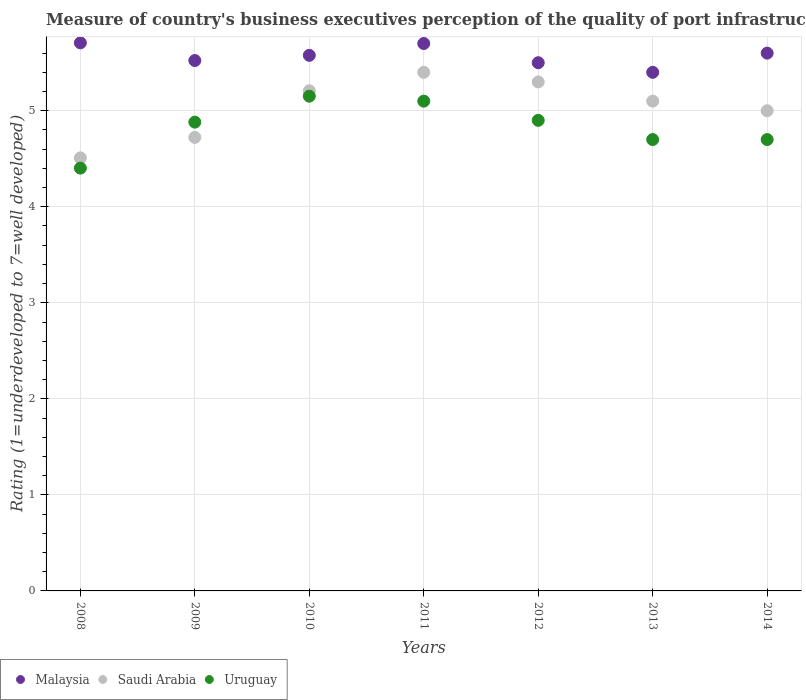How many different coloured dotlines are there?
Provide a short and direct response. 3. Is the number of dotlines equal to the number of legend labels?
Provide a short and direct response. Yes. What is the ratings of the quality of port infrastructure in Uruguay in 2014?
Ensure brevity in your answer.  4.7. Across all years, what is the maximum ratings of the quality of port infrastructure in Malaysia?
Provide a short and direct response. 5.71. In which year was the ratings of the quality of port infrastructure in Malaysia minimum?
Give a very brief answer. 2013. What is the total ratings of the quality of port infrastructure in Malaysia in the graph?
Your answer should be compact. 39.01. What is the difference between the ratings of the quality of port infrastructure in Malaysia in 2008 and that in 2010?
Make the answer very short. 0.13. What is the difference between the ratings of the quality of port infrastructure in Malaysia in 2013 and the ratings of the quality of port infrastructure in Saudi Arabia in 2012?
Give a very brief answer. 0.1. What is the average ratings of the quality of port infrastructure in Malaysia per year?
Your answer should be compact. 5.57. In the year 2014, what is the difference between the ratings of the quality of port infrastructure in Saudi Arabia and ratings of the quality of port infrastructure in Uruguay?
Make the answer very short. 0.3. What is the ratio of the ratings of the quality of port infrastructure in Uruguay in 2011 to that in 2014?
Ensure brevity in your answer.  1.09. Is the ratings of the quality of port infrastructure in Malaysia in 2011 less than that in 2013?
Provide a short and direct response. No. What is the difference between the highest and the second highest ratings of the quality of port infrastructure in Saudi Arabia?
Your answer should be compact. 0.1. What is the difference between the highest and the lowest ratings of the quality of port infrastructure in Uruguay?
Make the answer very short. 0.75. In how many years, is the ratings of the quality of port infrastructure in Uruguay greater than the average ratings of the quality of port infrastructure in Uruguay taken over all years?
Provide a succinct answer. 4. Is the sum of the ratings of the quality of port infrastructure in Uruguay in 2009 and 2010 greater than the maximum ratings of the quality of port infrastructure in Malaysia across all years?
Keep it short and to the point. Yes. Is it the case that in every year, the sum of the ratings of the quality of port infrastructure in Uruguay and ratings of the quality of port infrastructure in Malaysia  is greater than the ratings of the quality of port infrastructure in Saudi Arabia?
Provide a short and direct response. Yes. Is the ratings of the quality of port infrastructure in Saudi Arabia strictly greater than the ratings of the quality of port infrastructure in Malaysia over the years?
Offer a very short reply. No. Does the graph contain any zero values?
Offer a terse response. No. How many legend labels are there?
Make the answer very short. 3. How are the legend labels stacked?
Provide a short and direct response. Horizontal. What is the title of the graph?
Your answer should be very brief. Measure of country's business executives perception of the quality of port infrastructure. What is the label or title of the X-axis?
Provide a short and direct response. Years. What is the label or title of the Y-axis?
Your response must be concise. Rating (1=underdeveloped to 7=well developed). What is the Rating (1=underdeveloped to 7=well developed) in Malaysia in 2008?
Ensure brevity in your answer.  5.71. What is the Rating (1=underdeveloped to 7=well developed) of Saudi Arabia in 2008?
Offer a terse response. 4.51. What is the Rating (1=underdeveloped to 7=well developed) in Uruguay in 2008?
Ensure brevity in your answer.  4.4. What is the Rating (1=underdeveloped to 7=well developed) of Malaysia in 2009?
Offer a terse response. 5.52. What is the Rating (1=underdeveloped to 7=well developed) in Saudi Arabia in 2009?
Your response must be concise. 4.72. What is the Rating (1=underdeveloped to 7=well developed) of Uruguay in 2009?
Your answer should be compact. 4.88. What is the Rating (1=underdeveloped to 7=well developed) of Malaysia in 2010?
Your answer should be very brief. 5.58. What is the Rating (1=underdeveloped to 7=well developed) in Saudi Arabia in 2010?
Ensure brevity in your answer.  5.21. What is the Rating (1=underdeveloped to 7=well developed) in Uruguay in 2010?
Your response must be concise. 5.15. What is the Rating (1=underdeveloped to 7=well developed) in Saudi Arabia in 2011?
Ensure brevity in your answer.  5.4. What is the Rating (1=underdeveloped to 7=well developed) in Saudi Arabia in 2012?
Your answer should be very brief. 5.3. What is the Rating (1=underdeveloped to 7=well developed) in Uruguay in 2012?
Provide a succinct answer. 4.9. What is the Rating (1=underdeveloped to 7=well developed) of Malaysia in 2013?
Your response must be concise. 5.4. What is the Rating (1=underdeveloped to 7=well developed) in Uruguay in 2013?
Your response must be concise. 4.7. What is the Rating (1=underdeveloped to 7=well developed) of Malaysia in 2014?
Your answer should be compact. 5.6. Across all years, what is the maximum Rating (1=underdeveloped to 7=well developed) of Malaysia?
Keep it short and to the point. 5.71. Across all years, what is the maximum Rating (1=underdeveloped to 7=well developed) of Uruguay?
Provide a succinct answer. 5.15. Across all years, what is the minimum Rating (1=underdeveloped to 7=well developed) in Malaysia?
Provide a succinct answer. 5.4. Across all years, what is the minimum Rating (1=underdeveloped to 7=well developed) of Saudi Arabia?
Your answer should be compact. 4.51. Across all years, what is the minimum Rating (1=underdeveloped to 7=well developed) of Uruguay?
Offer a terse response. 4.4. What is the total Rating (1=underdeveloped to 7=well developed) of Malaysia in the graph?
Provide a succinct answer. 39.01. What is the total Rating (1=underdeveloped to 7=well developed) in Saudi Arabia in the graph?
Give a very brief answer. 35.24. What is the total Rating (1=underdeveloped to 7=well developed) in Uruguay in the graph?
Give a very brief answer. 33.84. What is the difference between the Rating (1=underdeveloped to 7=well developed) in Malaysia in 2008 and that in 2009?
Offer a terse response. 0.18. What is the difference between the Rating (1=underdeveloped to 7=well developed) of Saudi Arabia in 2008 and that in 2009?
Your answer should be very brief. -0.21. What is the difference between the Rating (1=underdeveloped to 7=well developed) of Uruguay in 2008 and that in 2009?
Your answer should be very brief. -0.48. What is the difference between the Rating (1=underdeveloped to 7=well developed) in Malaysia in 2008 and that in 2010?
Your answer should be compact. 0.13. What is the difference between the Rating (1=underdeveloped to 7=well developed) in Saudi Arabia in 2008 and that in 2010?
Offer a terse response. -0.7. What is the difference between the Rating (1=underdeveloped to 7=well developed) in Uruguay in 2008 and that in 2010?
Give a very brief answer. -0.75. What is the difference between the Rating (1=underdeveloped to 7=well developed) of Malaysia in 2008 and that in 2011?
Keep it short and to the point. 0.01. What is the difference between the Rating (1=underdeveloped to 7=well developed) of Saudi Arabia in 2008 and that in 2011?
Your response must be concise. -0.89. What is the difference between the Rating (1=underdeveloped to 7=well developed) of Uruguay in 2008 and that in 2011?
Offer a very short reply. -0.7. What is the difference between the Rating (1=underdeveloped to 7=well developed) in Malaysia in 2008 and that in 2012?
Your answer should be very brief. 0.21. What is the difference between the Rating (1=underdeveloped to 7=well developed) of Saudi Arabia in 2008 and that in 2012?
Offer a very short reply. -0.79. What is the difference between the Rating (1=underdeveloped to 7=well developed) of Uruguay in 2008 and that in 2012?
Keep it short and to the point. -0.5. What is the difference between the Rating (1=underdeveloped to 7=well developed) of Malaysia in 2008 and that in 2013?
Make the answer very short. 0.31. What is the difference between the Rating (1=underdeveloped to 7=well developed) of Saudi Arabia in 2008 and that in 2013?
Ensure brevity in your answer.  -0.59. What is the difference between the Rating (1=underdeveloped to 7=well developed) of Uruguay in 2008 and that in 2013?
Make the answer very short. -0.3. What is the difference between the Rating (1=underdeveloped to 7=well developed) of Malaysia in 2008 and that in 2014?
Your answer should be compact. 0.11. What is the difference between the Rating (1=underdeveloped to 7=well developed) in Saudi Arabia in 2008 and that in 2014?
Your answer should be compact. -0.49. What is the difference between the Rating (1=underdeveloped to 7=well developed) of Uruguay in 2008 and that in 2014?
Offer a terse response. -0.3. What is the difference between the Rating (1=underdeveloped to 7=well developed) of Malaysia in 2009 and that in 2010?
Your answer should be compact. -0.05. What is the difference between the Rating (1=underdeveloped to 7=well developed) of Saudi Arabia in 2009 and that in 2010?
Offer a very short reply. -0.49. What is the difference between the Rating (1=underdeveloped to 7=well developed) of Uruguay in 2009 and that in 2010?
Your answer should be very brief. -0.27. What is the difference between the Rating (1=underdeveloped to 7=well developed) of Malaysia in 2009 and that in 2011?
Your answer should be compact. -0.18. What is the difference between the Rating (1=underdeveloped to 7=well developed) of Saudi Arabia in 2009 and that in 2011?
Your answer should be very brief. -0.68. What is the difference between the Rating (1=underdeveloped to 7=well developed) of Uruguay in 2009 and that in 2011?
Your response must be concise. -0.22. What is the difference between the Rating (1=underdeveloped to 7=well developed) in Malaysia in 2009 and that in 2012?
Ensure brevity in your answer.  0.02. What is the difference between the Rating (1=underdeveloped to 7=well developed) in Saudi Arabia in 2009 and that in 2012?
Give a very brief answer. -0.58. What is the difference between the Rating (1=underdeveloped to 7=well developed) of Uruguay in 2009 and that in 2012?
Keep it short and to the point. -0.02. What is the difference between the Rating (1=underdeveloped to 7=well developed) in Malaysia in 2009 and that in 2013?
Provide a short and direct response. 0.12. What is the difference between the Rating (1=underdeveloped to 7=well developed) of Saudi Arabia in 2009 and that in 2013?
Your answer should be compact. -0.38. What is the difference between the Rating (1=underdeveloped to 7=well developed) in Uruguay in 2009 and that in 2013?
Offer a terse response. 0.18. What is the difference between the Rating (1=underdeveloped to 7=well developed) in Malaysia in 2009 and that in 2014?
Your answer should be very brief. -0.08. What is the difference between the Rating (1=underdeveloped to 7=well developed) of Saudi Arabia in 2009 and that in 2014?
Your answer should be very brief. -0.28. What is the difference between the Rating (1=underdeveloped to 7=well developed) of Uruguay in 2009 and that in 2014?
Make the answer very short. 0.18. What is the difference between the Rating (1=underdeveloped to 7=well developed) of Malaysia in 2010 and that in 2011?
Your answer should be very brief. -0.12. What is the difference between the Rating (1=underdeveloped to 7=well developed) of Saudi Arabia in 2010 and that in 2011?
Ensure brevity in your answer.  -0.19. What is the difference between the Rating (1=underdeveloped to 7=well developed) of Uruguay in 2010 and that in 2011?
Your answer should be compact. 0.05. What is the difference between the Rating (1=underdeveloped to 7=well developed) in Malaysia in 2010 and that in 2012?
Keep it short and to the point. 0.08. What is the difference between the Rating (1=underdeveloped to 7=well developed) of Saudi Arabia in 2010 and that in 2012?
Keep it short and to the point. -0.09. What is the difference between the Rating (1=underdeveloped to 7=well developed) in Uruguay in 2010 and that in 2012?
Offer a terse response. 0.25. What is the difference between the Rating (1=underdeveloped to 7=well developed) of Malaysia in 2010 and that in 2013?
Provide a short and direct response. 0.18. What is the difference between the Rating (1=underdeveloped to 7=well developed) in Saudi Arabia in 2010 and that in 2013?
Provide a short and direct response. 0.11. What is the difference between the Rating (1=underdeveloped to 7=well developed) of Uruguay in 2010 and that in 2013?
Ensure brevity in your answer.  0.45. What is the difference between the Rating (1=underdeveloped to 7=well developed) in Malaysia in 2010 and that in 2014?
Your answer should be very brief. -0.02. What is the difference between the Rating (1=underdeveloped to 7=well developed) of Saudi Arabia in 2010 and that in 2014?
Offer a very short reply. 0.21. What is the difference between the Rating (1=underdeveloped to 7=well developed) of Uruguay in 2010 and that in 2014?
Ensure brevity in your answer.  0.45. What is the difference between the Rating (1=underdeveloped to 7=well developed) in Uruguay in 2011 and that in 2012?
Your answer should be compact. 0.2. What is the difference between the Rating (1=underdeveloped to 7=well developed) of Malaysia in 2011 and that in 2013?
Ensure brevity in your answer.  0.3. What is the difference between the Rating (1=underdeveloped to 7=well developed) of Saudi Arabia in 2011 and that in 2013?
Ensure brevity in your answer.  0.3. What is the difference between the Rating (1=underdeveloped to 7=well developed) in Uruguay in 2011 and that in 2013?
Provide a succinct answer. 0.4. What is the difference between the Rating (1=underdeveloped to 7=well developed) in Malaysia in 2011 and that in 2014?
Your answer should be very brief. 0.1. What is the difference between the Rating (1=underdeveloped to 7=well developed) of Saudi Arabia in 2011 and that in 2014?
Provide a succinct answer. 0.4. What is the difference between the Rating (1=underdeveloped to 7=well developed) of Uruguay in 2011 and that in 2014?
Keep it short and to the point. 0.4. What is the difference between the Rating (1=underdeveloped to 7=well developed) in Uruguay in 2012 and that in 2013?
Keep it short and to the point. 0.2. What is the difference between the Rating (1=underdeveloped to 7=well developed) in Malaysia in 2013 and that in 2014?
Keep it short and to the point. -0.2. What is the difference between the Rating (1=underdeveloped to 7=well developed) of Malaysia in 2008 and the Rating (1=underdeveloped to 7=well developed) of Saudi Arabia in 2009?
Give a very brief answer. 0.98. What is the difference between the Rating (1=underdeveloped to 7=well developed) of Malaysia in 2008 and the Rating (1=underdeveloped to 7=well developed) of Uruguay in 2009?
Give a very brief answer. 0.83. What is the difference between the Rating (1=underdeveloped to 7=well developed) in Saudi Arabia in 2008 and the Rating (1=underdeveloped to 7=well developed) in Uruguay in 2009?
Offer a terse response. -0.37. What is the difference between the Rating (1=underdeveloped to 7=well developed) in Malaysia in 2008 and the Rating (1=underdeveloped to 7=well developed) in Saudi Arabia in 2010?
Make the answer very short. 0.5. What is the difference between the Rating (1=underdeveloped to 7=well developed) in Malaysia in 2008 and the Rating (1=underdeveloped to 7=well developed) in Uruguay in 2010?
Your answer should be very brief. 0.56. What is the difference between the Rating (1=underdeveloped to 7=well developed) in Saudi Arabia in 2008 and the Rating (1=underdeveloped to 7=well developed) in Uruguay in 2010?
Offer a very short reply. -0.64. What is the difference between the Rating (1=underdeveloped to 7=well developed) in Malaysia in 2008 and the Rating (1=underdeveloped to 7=well developed) in Saudi Arabia in 2011?
Give a very brief answer. 0.31. What is the difference between the Rating (1=underdeveloped to 7=well developed) in Malaysia in 2008 and the Rating (1=underdeveloped to 7=well developed) in Uruguay in 2011?
Provide a short and direct response. 0.61. What is the difference between the Rating (1=underdeveloped to 7=well developed) in Saudi Arabia in 2008 and the Rating (1=underdeveloped to 7=well developed) in Uruguay in 2011?
Your answer should be compact. -0.59. What is the difference between the Rating (1=underdeveloped to 7=well developed) in Malaysia in 2008 and the Rating (1=underdeveloped to 7=well developed) in Saudi Arabia in 2012?
Your response must be concise. 0.41. What is the difference between the Rating (1=underdeveloped to 7=well developed) in Malaysia in 2008 and the Rating (1=underdeveloped to 7=well developed) in Uruguay in 2012?
Your response must be concise. 0.81. What is the difference between the Rating (1=underdeveloped to 7=well developed) of Saudi Arabia in 2008 and the Rating (1=underdeveloped to 7=well developed) of Uruguay in 2012?
Ensure brevity in your answer.  -0.39. What is the difference between the Rating (1=underdeveloped to 7=well developed) in Malaysia in 2008 and the Rating (1=underdeveloped to 7=well developed) in Saudi Arabia in 2013?
Your response must be concise. 0.61. What is the difference between the Rating (1=underdeveloped to 7=well developed) of Saudi Arabia in 2008 and the Rating (1=underdeveloped to 7=well developed) of Uruguay in 2013?
Provide a succinct answer. -0.19. What is the difference between the Rating (1=underdeveloped to 7=well developed) of Malaysia in 2008 and the Rating (1=underdeveloped to 7=well developed) of Saudi Arabia in 2014?
Make the answer very short. 0.71. What is the difference between the Rating (1=underdeveloped to 7=well developed) of Saudi Arabia in 2008 and the Rating (1=underdeveloped to 7=well developed) of Uruguay in 2014?
Make the answer very short. -0.19. What is the difference between the Rating (1=underdeveloped to 7=well developed) in Malaysia in 2009 and the Rating (1=underdeveloped to 7=well developed) in Saudi Arabia in 2010?
Provide a short and direct response. 0.31. What is the difference between the Rating (1=underdeveloped to 7=well developed) in Malaysia in 2009 and the Rating (1=underdeveloped to 7=well developed) in Uruguay in 2010?
Your response must be concise. 0.37. What is the difference between the Rating (1=underdeveloped to 7=well developed) in Saudi Arabia in 2009 and the Rating (1=underdeveloped to 7=well developed) in Uruguay in 2010?
Provide a succinct answer. -0.43. What is the difference between the Rating (1=underdeveloped to 7=well developed) of Malaysia in 2009 and the Rating (1=underdeveloped to 7=well developed) of Saudi Arabia in 2011?
Your answer should be very brief. 0.12. What is the difference between the Rating (1=underdeveloped to 7=well developed) in Malaysia in 2009 and the Rating (1=underdeveloped to 7=well developed) in Uruguay in 2011?
Ensure brevity in your answer.  0.42. What is the difference between the Rating (1=underdeveloped to 7=well developed) of Saudi Arabia in 2009 and the Rating (1=underdeveloped to 7=well developed) of Uruguay in 2011?
Make the answer very short. -0.38. What is the difference between the Rating (1=underdeveloped to 7=well developed) in Malaysia in 2009 and the Rating (1=underdeveloped to 7=well developed) in Saudi Arabia in 2012?
Your answer should be very brief. 0.22. What is the difference between the Rating (1=underdeveloped to 7=well developed) in Malaysia in 2009 and the Rating (1=underdeveloped to 7=well developed) in Uruguay in 2012?
Offer a terse response. 0.62. What is the difference between the Rating (1=underdeveloped to 7=well developed) in Saudi Arabia in 2009 and the Rating (1=underdeveloped to 7=well developed) in Uruguay in 2012?
Your response must be concise. -0.18. What is the difference between the Rating (1=underdeveloped to 7=well developed) of Malaysia in 2009 and the Rating (1=underdeveloped to 7=well developed) of Saudi Arabia in 2013?
Give a very brief answer. 0.42. What is the difference between the Rating (1=underdeveloped to 7=well developed) in Malaysia in 2009 and the Rating (1=underdeveloped to 7=well developed) in Uruguay in 2013?
Keep it short and to the point. 0.82. What is the difference between the Rating (1=underdeveloped to 7=well developed) of Saudi Arabia in 2009 and the Rating (1=underdeveloped to 7=well developed) of Uruguay in 2013?
Make the answer very short. 0.02. What is the difference between the Rating (1=underdeveloped to 7=well developed) in Malaysia in 2009 and the Rating (1=underdeveloped to 7=well developed) in Saudi Arabia in 2014?
Your answer should be compact. 0.52. What is the difference between the Rating (1=underdeveloped to 7=well developed) of Malaysia in 2009 and the Rating (1=underdeveloped to 7=well developed) of Uruguay in 2014?
Provide a succinct answer. 0.82. What is the difference between the Rating (1=underdeveloped to 7=well developed) in Saudi Arabia in 2009 and the Rating (1=underdeveloped to 7=well developed) in Uruguay in 2014?
Provide a succinct answer. 0.02. What is the difference between the Rating (1=underdeveloped to 7=well developed) of Malaysia in 2010 and the Rating (1=underdeveloped to 7=well developed) of Saudi Arabia in 2011?
Give a very brief answer. 0.18. What is the difference between the Rating (1=underdeveloped to 7=well developed) of Malaysia in 2010 and the Rating (1=underdeveloped to 7=well developed) of Uruguay in 2011?
Give a very brief answer. 0.48. What is the difference between the Rating (1=underdeveloped to 7=well developed) in Saudi Arabia in 2010 and the Rating (1=underdeveloped to 7=well developed) in Uruguay in 2011?
Keep it short and to the point. 0.11. What is the difference between the Rating (1=underdeveloped to 7=well developed) of Malaysia in 2010 and the Rating (1=underdeveloped to 7=well developed) of Saudi Arabia in 2012?
Ensure brevity in your answer.  0.28. What is the difference between the Rating (1=underdeveloped to 7=well developed) in Malaysia in 2010 and the Rating (1=underdeveloped to 7=well developed) in Uruguay in 2012?
Ensure brevity in your answer.  0.68. What is the difference between the Rating (1=underdeveloped to 7=well developed) in Saudi Arabia in 2010 and the Rating (1=underdeveloped to 7=well developed) in Uruguay in 2012?
Offer a very short reply. 0.31. What is the difference between the Rating (1=underdeveloped to 7=well developed) in Malaysia in 2010 and the Rating (1=underdeveloped to 7=well developed) in Saudi Arabia in 2013?
Your response must be concise. 0.48. What is the difference between the Rating (1=underdeveloped to 7=well developed) of Malaysia in 2010 and the Rating (1=underdeveloped to 7=well developed) of Uruguay in 2013?
Offer a terse response. 0.88. What is the difference between the Rating (1=underdeveloped to 7=well developed) in Saudi Arabia in 2010 and the Rating (1=underdeveloped to 7=well developed) in Uruguay in 2013?
Provide a short and direct response. 0.51. What is the difference between the Rating (1=underdeveloped to 7=well developed) of Malaysia in 2010 and the Rating (1=underdeveloped to 7=well developed) of Saudi Arabia in 2014?
Ensure brevity in your answer.  0.58. What is the difference between the Rating (1=underdeveloped to 7=well developed) in Malaysia in 2010 and the Rating (1=underdeveloped to 7=well developed) in Uruguay in 2014?
Make the answer very short. 0.88. What is the difference between the Rating (1=underdeveloped to 7=well developed) of Saudi Arabia in 2010 and the Rating (1=underdeveloped to 7=well developed) of Uruguay in 2014?
Ensure brevity in your answer.  0.51. What is the difference between the Rating (1=underdeveloped to 7=well developed) of Malaysia in 2011 and the Rating (1=underdeveloped to 7=well developed) of Saudi Arabia in 2012?
Make the answer very short. 0.4. What is the difference between the Rating (1=underdeveloped to 7=well developed) of Malaysia in 2011 and the Rating (1=underdeveloped to 7=well developed) of Uruguay in 2012?
Keep it short and to the point. 0.8. What is the difference between the Rating (1=underdeveloped to 7=well developed) of Malaysia in 2011 and the Rating (1=underdeveloped to 7=well developed) of Uruguay in 2013?
Your answer should be very brief. 1. What is the difference between the Rating (1=underdeveloped to 7=well developed) of Saudi Arabia in 2011 and the Rating (1=underdeveloped to 7=well developed) of Uruguay in 2013?
Your answer should be compact. 0.7. What is the difference between the Rating (1=underdeveloped to 7=well developed) of Malaysia in 2011 and the Rating (1=underdeveloped to 7=well developed) of Saudi Arabia in 2014?
Keep it short and to the point. 0.7. What is the difference between the Rating (1=underdeveloped to 7=well developed) of Malaysia in 2012 and the Rating (1=underdeveloped to 7=well developed) of Saudi Arabia in 2013?
Your response must be concise. 0.4. What is the difference between the Rating (1=underdeveloped to 7=well developed) of Saudi Arabia in 2012 and the Rating (1=underdeveloped to 7=well developed) of Uruguay in 2013?
Provide a short and direct response. 0.6. What is the difference between the Rating (1=underdeveloped to 7=well developed) of Malaysia in 2012 and the Rating (1=underdeveloped to 7=well developed) of Uruguay in 2014?
Provide a succinct answer. 0.8. What is the difference between the Rating (1=underdeveloped to 7=well developed) of Malaysia in 2013 and the Rating (1=underdeveloped to 7=well developed) of Saudi Arabia in 2014?
Keep it short and to the point. 0.4. What is the difference between the Rating (1=underdeveloped to 7=well developed) of Malaysia in 2013 and the Rating (1=underdeveloped to 7=well developed) of Uruguay in 2014?
Your response must be concise. 0.7. What is the difference between the Rating (1=underdeveloped to 7=well developed) in Saudi Arabia in 2013 and the Rating (1=underdeveloped to 7=well developed) in Uruguay in 2014?
Provide a succinct answer. 0.4. What is the average Rating (1=underdeveloped to 7=well developed) in Malaysia per year?
Provide a short and direct response. 5.57. What is the average Rating (1=underdeveloped to 7=well developed) in Saudi Arabia per year?
Keep it short and to the point. 5.03. What is the average Rating (1=underdeveloped to 7=well developed) in Uruguay per year?
Ensure brevity in your answer.  4.83. In the year 2008, what is the difference between the Rating (1=underdeveloped to 7=well developed) in Malaysia and Rating (1=underdeveloped to 7=well developed) in Saudi Arabia?
Ensure brevity in your answer.  1.2. In the year 2008, what is the difference between the Rating (1=underdeveloped to 7=well developed) in Malaysia and Rating (1=underdeveloped to 7=well developed) in Uruguay?
Your answer should be compact. 1.3. In the year 2008, what is the difference between the Rating (1=underdeveloped to 7=well developed) of Saudi Arabia and Rating (1=underdeveloped to 7=well developed) of Uruguay?
Keep it short and to the point. 0.11. In the year 2009, what is the difference between the Rating (1=underdeveloped to 7=well developed) in Malaysia and Rating (1=underdeveloped to 7=well developed) in Saudi Arabia?
Your answer should be compact. 0.8. In the year 2009, what is the difference between the Rating (1=underdeveloped to 7=well developed) in Malaysia and Rating (1=underdeveloped to 7=well developed) in Uruguay?
Give a very brief answer. 0.64. In the year 2009, what is the difference between the Rating (1=underdeveloped to 7=well developed) of Saudi Arabia and Rating (1=underdeveloped to 7=well developed) of Uruguay?
Provide a short and direct response. -0.16. In the year 2010, what is the difference between the Rating (1=underdeveloped to 7=well developed) in Malaysia and Rating (1=underdeveloped to 7=well developed) in Saudi Arabia?
Your response must be concise. 0.37. In the year 2010, what is the difference between the Rating (1=underdeveloped to 7=well developed) of Malaysia and Rating (1=underdeveloped to 7=well developed) of Uruguay?
Make the answer very short. 0.43. In the year 2010, what is the difference between the Rating (1=underdeveloped to 7=well developed) of Saudi Arabia and Rating (1=underdeveloped to 7=well developed) of Uruguay?
Your answer should be very brief. 0.06. In the year 2011, what is the difference between the Rating (1=underdeveloped to 7=well developed) in Malaysia and Rating (1=underdeveloped to 7=well developed) in Saudi Arabia?
Make the answer very short. 0.3. In the year 2011, what is the difference between the Rating (1=underdeveloped to 7=well developed) in Malaysia and Rating (1=underdeveloped to 7=well developed) in Uruguay?
Make the answer very short. 0.6. In the year 2011, what is the difference between the Rating (1=underdeveloped to 7=well developed) in Saudi Arabia and Rating (1=underdeveloped to 7=well developed) in Uruguay?
Offer a terse response. 0.3. In the year 2012, what is the difference between the Rating (1=underdeveloped to 7=well developed) of Malaysia and Rating (1=underdeveloped to 7=well developed) of Uruguay?
Provide a short and direct response. 0.6. In the year 2012, what is the difference between the Rating (1=underdeveloped to 7=well developed) in Saudi Arabia and Rating (1=underdeveloped to 7=well developed) in Uruguay?
Your response must be concise. 0.4. In the year 2013, what is the difference between the Rating (1=underdeveloped to 7=well developed) of Saudi Arabia and Rating (1=underdeveloped to 7=well developed) of Uruguay?
Your response must be concise. 0.4. In the year 2014, what is the difference between the Rating (1=underdeveloped to 7=well developed) of Saudi Arabia and Rating (1=underdeveloped to 7=well developed) of Uruguay?
Offer a terse response. 0.3. What is the ratio of the Rating (1=underdeveloped to 7=well developed) of Malaysia in 2008 to that in 2009?
Keep it short and to the point. 1.03. What is the ratio of the Rating (1=underdeveloped to 7=well developed) of Saudi Arabia in 2008 to that in 2009?
Your response must be concise. 0.95. What is the ratio of the Rating (1=underdeveloped to 7=well developed) of Uruguay in 2008 to that in 2009?
Give a very brief answer. 0.9. What is the ratio of the Rating (1=underdeveloped to 7=well developed) in Malaysia in 2008 to that in 2010?
Offer a terse response. 1.02. What is the ratio of the Rating (1=underdeveloped to 7=well developed) of Saudi Arabia in 2008 to that in 2010?
Provide a short and direct response. 0.87. What is the ratio of the Rating (1=underdeveloped to 7=well developed) of Uruguay in 2008 to that in 2010?
Ensure brevity in your answer.  0.85. What is the ratio of the Rating (1=underdeveloped to 7=well developed) in Malaysia in 2008 to that in 2011?
Make the answer very short. 1. What is the ratio of the Rating (1=underdeveloped to 7=well developed) in Saudi Arabia in 2008 to that in 2011?
Your response must be concise. 0.84. What is the ratio of the Rating (1=underdeveloped to 7=well developed) of Uruguay in 2008 to that in 2011?
Offer a very short reply. 0.86. What is the ratio of the Rating (1=underdeveloped to 7=well developed) in Malaysia in 2008 to that in 2012?
Your response must be concise. 1.04. What is the ratio of the Rating (1=underdeveloped to 7=well developed) of Saudi Arabia in 2008 to that in 2012?
Your response must be concise. 0.85. What is the ratio of the Rating (1=underdeveloped to 7=well developed) of Uruguay in 2008 to that in 2012?
Ensure brevity in your answer.  0.9. What is the ratio of the Rating (1=underdeveloped to 7=well developed) of Malaysia in 2008 to that in 2013?
Your answer should be very brief. 1.06. What is the ratio of the Rating (1=underdeveloped to 7=well developed) in Saudi Arabia in 2008 to that in 2013?
Your answer should be compact. 0.88. What is the ratio of the Rating (1=underdeveloped to 7=well developed) in Uruguay in 2008 to that in 2013?
Your response must be concise. 0.94. What is the ratio of the Rating (1=underdeveloped to 7=well developed) of Malaysia in 2008 to that in 2014?
Give a very brief answer. 1.02. What is the ratio of the Rating (1=underdeveloped to 7=well developed) in Saudi Arabia in 2008 to that in 2014?
Offer a terse response. 0.9. What is the ratio of the Rating (1=underdeveloped to 7=well developed) of Uruguay in 2008 to that in 2014?
Ensure brevity in your answer.  0.94. What is the ratio of the Rating (1=underdeveloped to 7=well developed) of Malaysia in 2009 to that in 2010?
Your answer should be very brief. 0.99. What is the ratio of the Rating (1=underdeveloped to 7=well developed) of Saudi Arabia in 2009 to that in 2010?
Ensure brevity in your answer.  0.91. What is the ratio of the Rating (1=underdeveloped to 7=well developed) of Uruguay in 2009 to that in 2010?
Your answer should be very brief. 0.95. What is the ratio of the Rating (1=underdeveloped to 7=well developed) in Malaysia in 2009 to that in 2011?
Your answer should be compact. 0.97. What is the ratio of the Rating (1=underdeveloped to 7=well developed) in Saudi Arabia in 2009 to that in 2011?
Your response must be concise. 0.87. What is the ratio of the Rating (1=underdeveloped to 7=well developed) of Uruguay in 2009 to that in 2011?
Offer a very short reply. 0.96. What is the ratio of the Rating (1=underdeveloped to 7=well developed) of Malaysia in 2009 to that in 2012?
Offer a terse response. 1. What is the ratio of the Rating (1=underdeveloped to 7=well developed) in Saudi Arabia in 2009 to that in 2012?
Provide a short and direct response. 0.89. What is the ratio of the Rating (1=underdeveloped to 7=well developed) in Uruguay in 2009 to that in 2012?
Ensure brevity in your answer.  1. What is the ratio of the Rating (1=underdeveloped to 7=well developed) in Malaysia in 2009 to that in 2013?
Offer a very short reply. 1.02. What is the ratio of the Rating (1=underdeveloped to 7=well developed) of Saudi Arabia in 2009 to that in 2013?
Provide a short and direct response. 0.93. What is the ratio of the Rating (1=underdeveloped to 7=well developed) in Uruguay in 2009 to that in 2013?
Offer a terse response. 1.04. What is the ratio of the Rating (1=underdeveloped to 7=well developed) of Malaysia in 2009 to that in 2014?
Ensure brevity in your answer.  0.99. What is the ratio of the Rating (1=underdeveloped to 7=well developed) of Saudi Arabia in 2009 to that in 2014?
Make the answer very short. 0.94. What is the ratio of the Rating (1=underdeveloped to 7=well developed) of Uruguay in 2009 to that in 2014?
Offer a terse response. 1.04. What is the ratio of the Rating (1=underdeveloped to 7=well developed) in Malaysia in 2010 to that in 2011?
Ensure brevity in your answer.  0.98. What is the ratio of the Rating (1=underdeveloped to 7=well developed) in Saudi Arabia in 2010 to that in 2011?
Offer a very short reply. 0.96. What is the ratio of the Rating (1=underdeveloped to 7=well developed) of Uruguay in 2010 to that in 2011?
Ensure brevity in your answer.  1.01. What is the ratio of the Rating (1=underdeveloped to 7=well developed) in Malaysia in 2010 to that in 2012?
Provide a short and direct response. 1.01. What is the ratio of the Rating (1=underdeveloped to 7=well developed) in Saudi Arabia in 2010 to that in 2012?
Provide a short and direct response. 0.98. What is the ratio of the Rating (1=underdeveloped to 7=well developed) of Uruguay in 2010 to that in 2012?
Your answer should be very brief. 1.05. What is the ratio of the Rating (1=underdeveloped to 7=well developed) of Malaysia in 2010 to that in 2013?
Keep it short and to the point. 1.03. What is the ratio of the Rating (1=underdeveloped to 7=well developed) in Saudi Arabia in 2010 to that in 2013?
Provide a succinct answer. 1.02. What is the ratio of the Rating (1=underdeveloped to 7=well developed) in Uruguay in 2010 to that in 2013?
Offer a very short reply. 1.1. What is the ratio of the Rating (1=underdeveloped to 7=well developed) of Malaysia in 2010 to that in 2014?
Ensure brevity in your answer.  1. What is the ratio of the Rating (1=underdeveloped to 7=well developed) in Saudi Arabia in 2010 to that in 2014?
Ensure brevity in your answer.  1.04. What is the ratio of the Rating (1=underdeveloped to 7=well developed) of Uruguay in 2010 to that in 2014?
Your response must be concise. 1.1. What is the ratio of the Rating (1=underdeveloped to 7=well developed) of Malaysia in 2011 to that in 2012?
Offer a terse response. 1.04. What is the ratio of the Rating (1=underdeveloped to 7=well developed) of Saudi Arabia in 2011 to that in 2012?
Offer a very short reply. 1.02. What is the ratio of the Rating (1=underdeveloped to 7=well developed) of Uruguay in 2011 to that in 2012?
Give a very brief answer. 1.04. What is the ratio of the Rating (1=underdeveloped to 7=well developed) in Malaysia in 2011 to that in 2013?
Your answer should be compact. 1.06. What is the ratio of the Rating (1=underdeveloped to 7=well developed) in Saudi Arabia in 2011 to that in 2013?
Provide a short and direct response. 1.06. What is the ratio of the Rating (1=underdeveloped to 7=well developed) in Uruguay in 2011 to that in 2013?
Offer a terse response. 1.09. What is the ratio of the Rating (1=underdeveloped to 7=well developed) in Malaysia in 2011 to that in 2014?
Give a very brief answer. 1.02. What is the ratio of the Rating (1=underdeveloped to 7=well developed) in Saudi Arabia in 2011 to that in 2014?
Keep it short and to the point. 1.08. What is the ratio of the Rating (1=underdeveloped to 7=well developed) of Uruguay in 2011 to that in 2014?
Offer a terse response. 1.09. What is the ratio of the Rating (1=underdeveloped to 7=well developed) of Malaysia in 2012 to that in 2013?
Offer a very short reply. 1.02. What is the ratio of the Rating (1=underdeveloped to 7=well developed) of Saudi Arabia in 2012 to that in 2013?
Offer a terse response. 1.04. What is the ratio of the Rating (1=underdeveloped to 7=well developed) in Uruguay in 2012 to that in 2013?
Keep it short and to the point. 1.04. What is the ratio of the Rating (1=underdeveloped to 7=well developed) of Malaysia in 2012 to that in 2014?
Offer a very short reply. 0.98. What is the ratio of the Rating (1=underdeveloped to 7=well developed) in Saudi Arabia in 2012 to that in 2014?
Your response must be concise. 1.06. What is the ratio of the Rating (1=underdeveloped to 7=well developed) in Uruguay in 2012 to that in 2014?
Your answer should be compact. 1.04. What is the ratio of the Rating (1=underdeveloped to 7=well developed) of Malaysia in 2013 to that in 2014?
Provide a succinct answer. 0.96. What is the ratio of the Rating (1=underdeveloped to 7=well developed) in Saudi Arabia in 2013 to that in 2014?
Keep it short and to the point. 1.02. What is the ratio of the Rating (1=underdeveloped to 7=well developed) in Uruguay in 2013 to that in 2014?
Keep it short and to the point. 1. What is the difference between the highest and the second highest Rating (1=underdeveloped to 7=well developed) in Malaysia?
Provide a short and direct response. 0.01. What is the difference between the highest and the second highest Rating (1=underdeveloped to 7=well developed) in Saudi Arabia?
Give a very brief answer. 0.1. What is the difference between the highest and the second highest Rating (1=underdeveloped to 7=well developed) of Uruguay?
Your answer should be compact. 0.05. What is the difference between the highest and the lowest Rating (1=underdeveloped to 7=well developed) of Malaysia?
Offer a terse response. 0.31. What is the difference between the highest and the lowest Rating (1=underdeveloped to 7=well developed) of Saudi Arabia?
Offer a very short reply. 0.89. What is the difference between the highest and the lowest Rating (1=underdeveloped to 7=well developed) in Uruguay?
Offer a terse response. 0.75. 